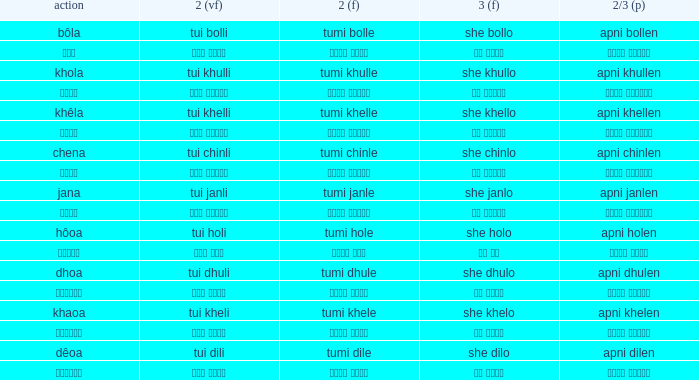What is the verb for তুমি খেলে? খাওয়া. Could you parse the entire table as a dict? {'header': ['action', '2 (vf)', '2 (f)', '3 (f)', '2/3 (p)'], 'rows': [['bôla', 'tui bolli', 'tumi bolle', 'she bollo', 'apni bollen'], ['বলা', 'তুই বললি', 'তুমি বললে', 'সে বললো', 'আপনি বললেন'], ['khola', 'tui khulli', 'tumi khulle', 'she khullo', 'apni khullen'], ['খোলা', 'তুই খুললি', 'তুমি খুললে', 'সে খুললো', 'আপনি খুললেন'], ['khêla', 'tui khelli', 'tumi khelle', 'she khello', 'apni khellen'], ['খেলে', 'তুই খেললি', 'তুমি খেললে', 'সে খেললো', 'আপনি খেললেন'], ['chena', 'tui chinli', 'tumi chinle', 'she chinlo', 'apni chinlen'], ['চেনা', 'তুই চিনলি', 'তুমি চিনলে', 'সে চিনলো', 'আপনি চিনলেন'], ['jana', 'tui janli', 'tumi janle', 'she janlo', 'apni janlen'], ['জানা', 'তুই জানলি', 'তুমি জানলে', 'সে জানলে', 'আপনি জানলেন'], ['hôoa', 'tui holi', 'tumi hole', 'she holo', 'apni holen'], ['হওয়া', 'তুই হলি', 'তুমি হলে', 'সে হল', 'আপনি হলেন'], ['dhoa', 'tui dhuli', 'tumi dhule', 'she dhulo', 'apni dhulen'], ['ধোওয়া', 'তুই ধুলি', 'তুমি ধুলে', 'সে ধুলো', 'আপনি ধুলেন'], ['khaoa', 'tui kheli', 'tumi khele', 'she khelo', 'apni khelen'], ['খাওয়া', 'তুই খেলি', 'তুমি খেলে', 'সে খেলো', 'আপনি খেলেন'], ['dêoa', 'tui dili', 'tumi dile', 'she dilo', 'apni dilen'], ['দেওয়া', 'তুই দিলি', 'তুমি দিলে', 'সে দিলো', 'আপনি দিলেন']]} 